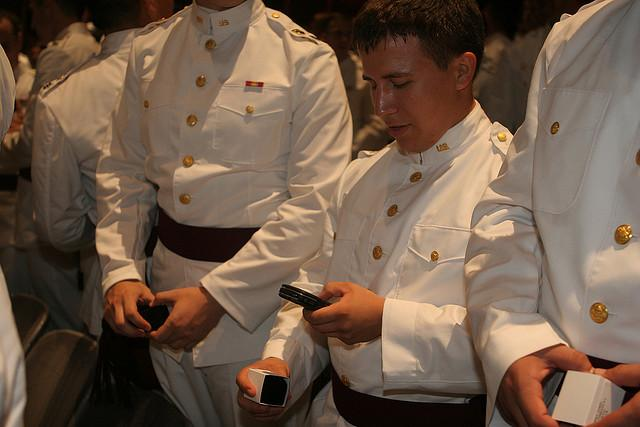What is the short man doing? texting 